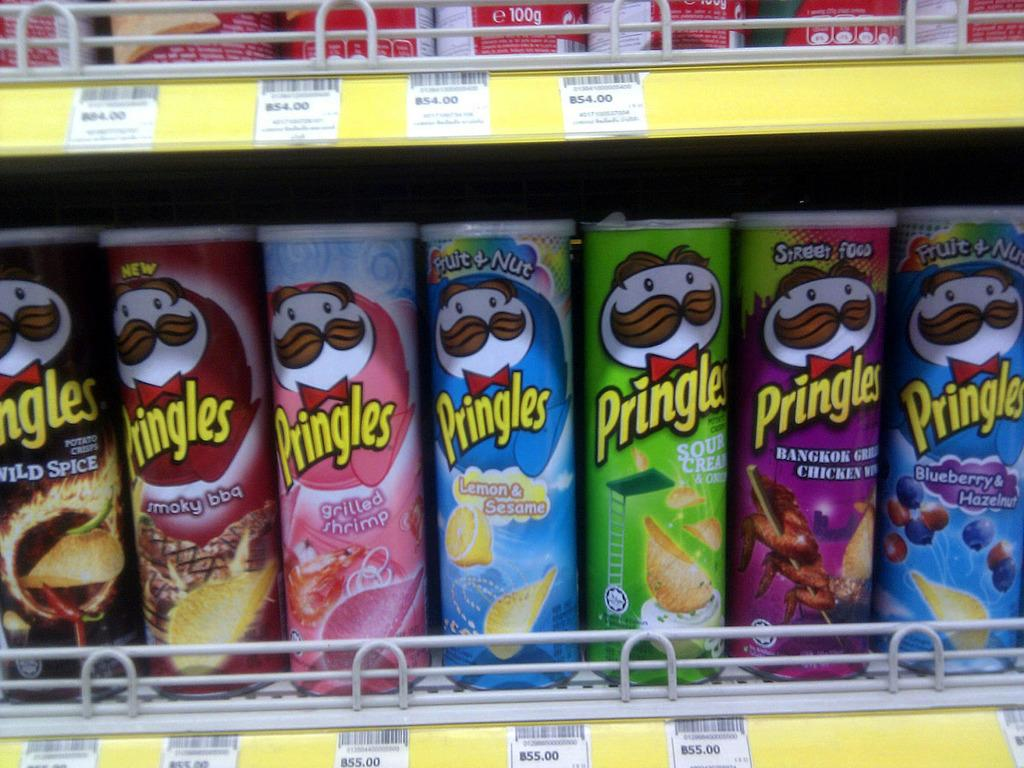<image>
Render a clear and concise summary of the photo. Many kinds of Pringles chips line the store shelves, including grilled shrimp flavor. 